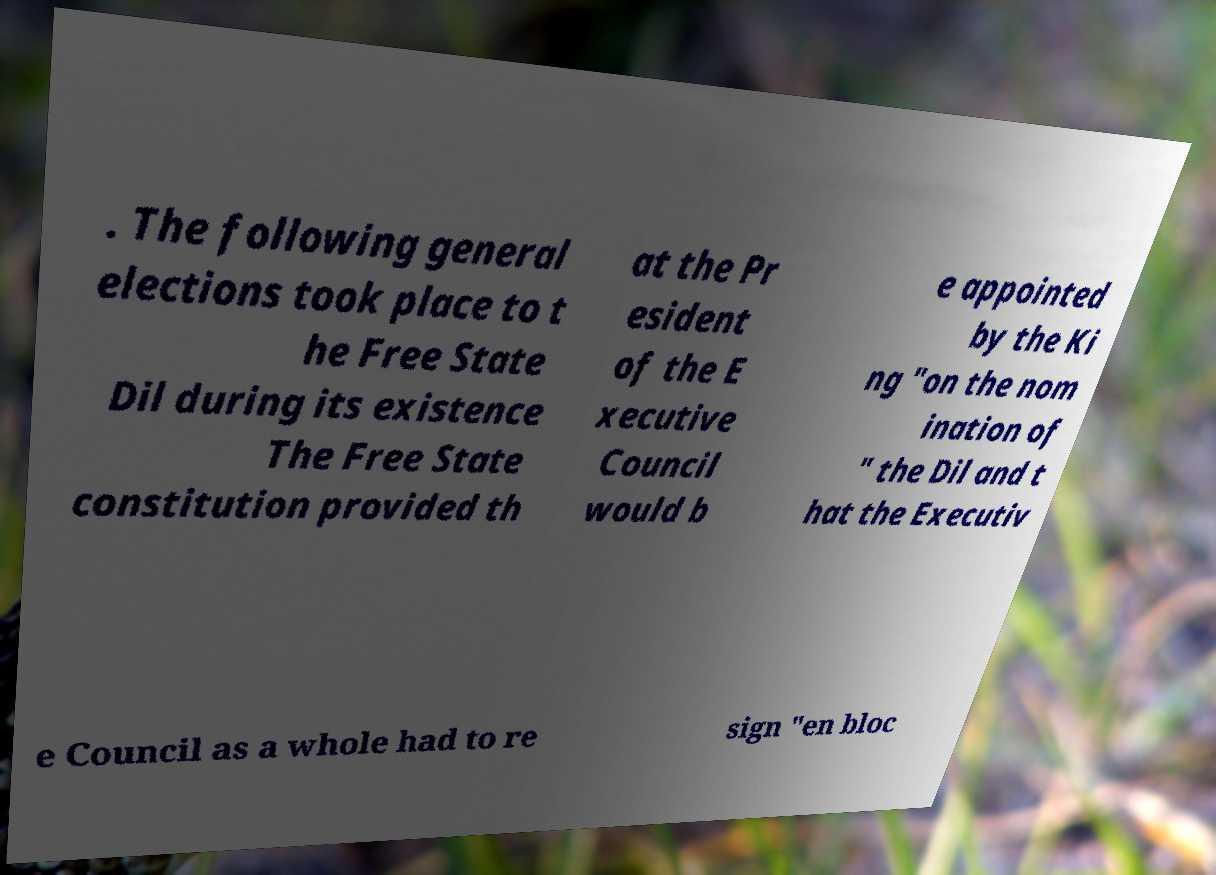Could you extract and type out the text from this image? . The following general elections took place to t he Free State Dil during its existence The Free State constitution provided th at the Pr esident of the E xecutive Council would b e appointed by the Ki ng "on the nom ination of " the Dil and t hat the Executiv e Council as a whole had to re sign "en bloc 